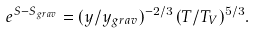Convert formula to latex. <formula><loc_0><loc_0><loc_500><loc_500>e ^ { S - S _ { g r a v } } = ( y / y _ { g r a v } ) ^ { - 2 / 3 } \, ( T / T _ { V } ) ^ { 5 / 3 } .</formula> 